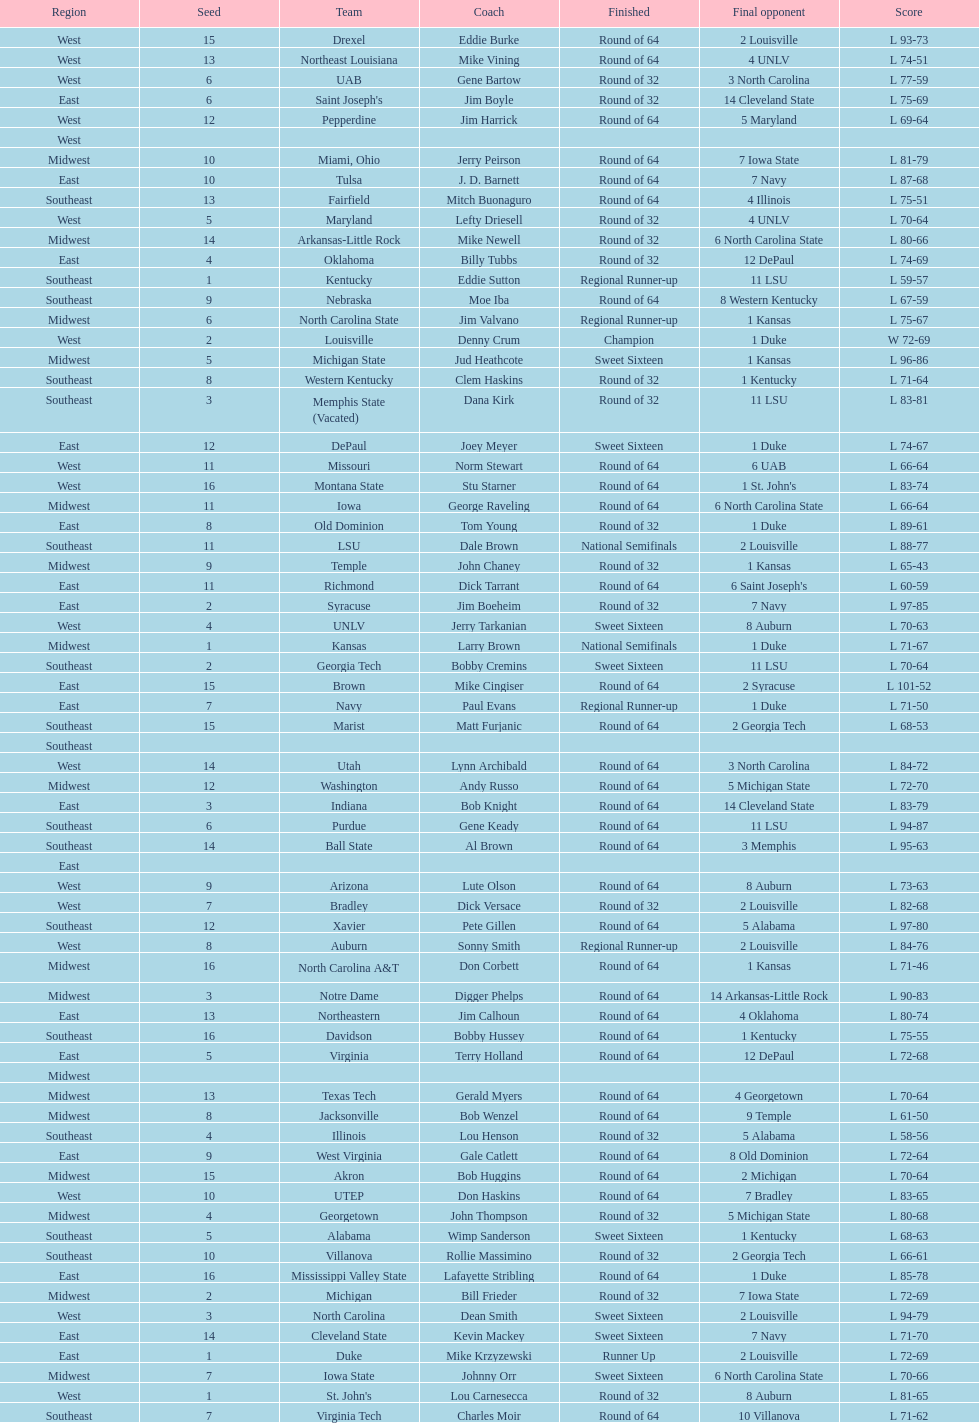How many 1 seeds are there? 4. 